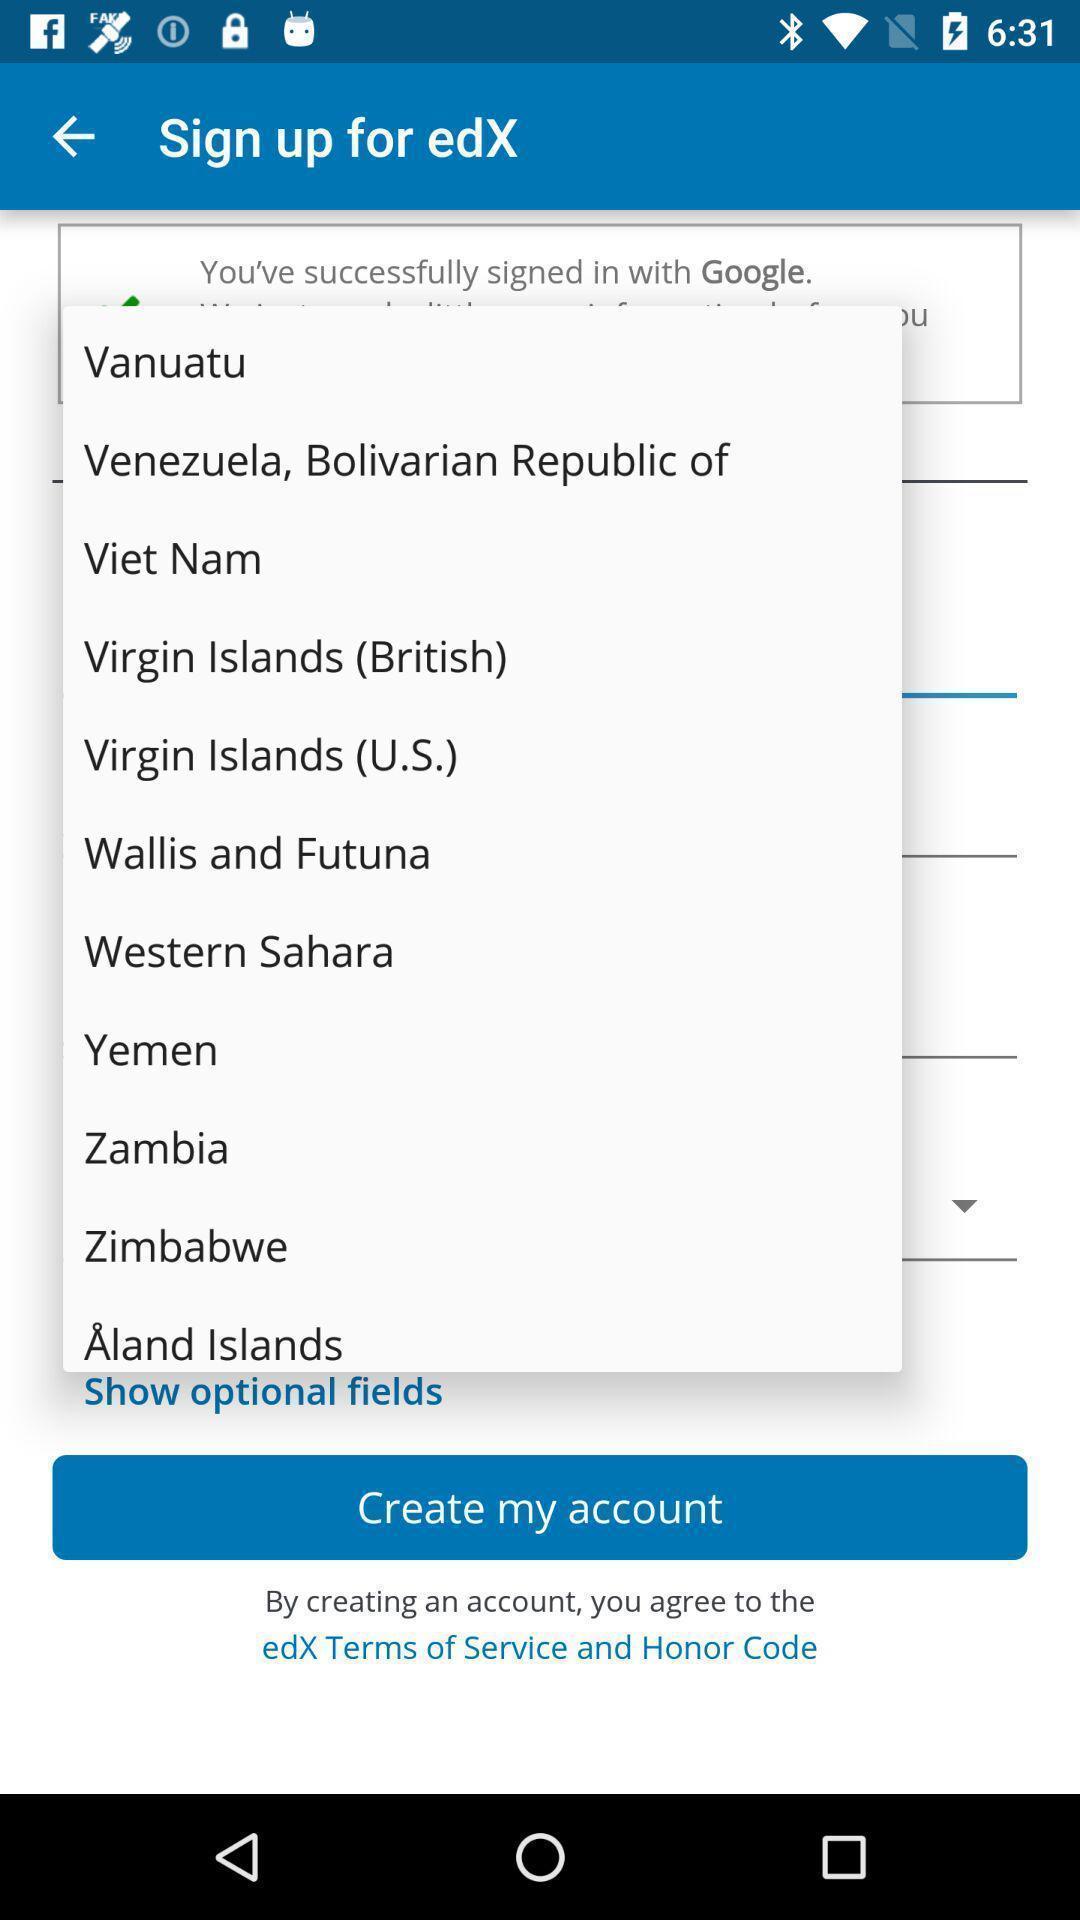Give me a summary of this screen capture. Screen showing countries. 